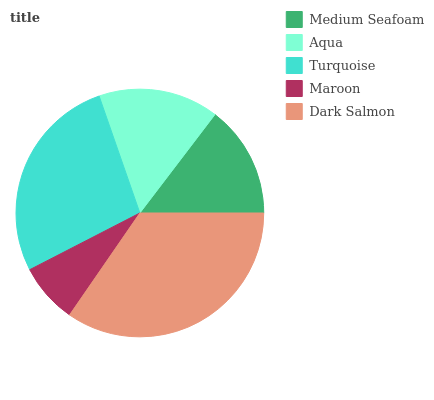Is Maroon the minimum?
Answer yes or no. Yes. Is Dark Salmon the maximum?
Answer yes or no. Yes. Is Aqua the minimum?
Answer yes or no. No. Is Aqua the maximum?
Answer yes or no. No. Is Aqua greater than Medium Seafoam?
Answer yes or no. Yes. Is Medium Seafoam less than Aqua?
Answer yes or no. Yes. Is Medium Seafoam greater than Aqua?
Answer yes or no. No. Is Aqua less than Medium Seafoam?
Answer yes or no. No. Is Aqua the high median?
Answer yes or no. Yes. Is Aqua the low median?
Answer yes or no. Yes. Is Turquoise the high median?
Answer yes or no. No. Is Dark Salmon the low median?
Answer yes or no. No. 